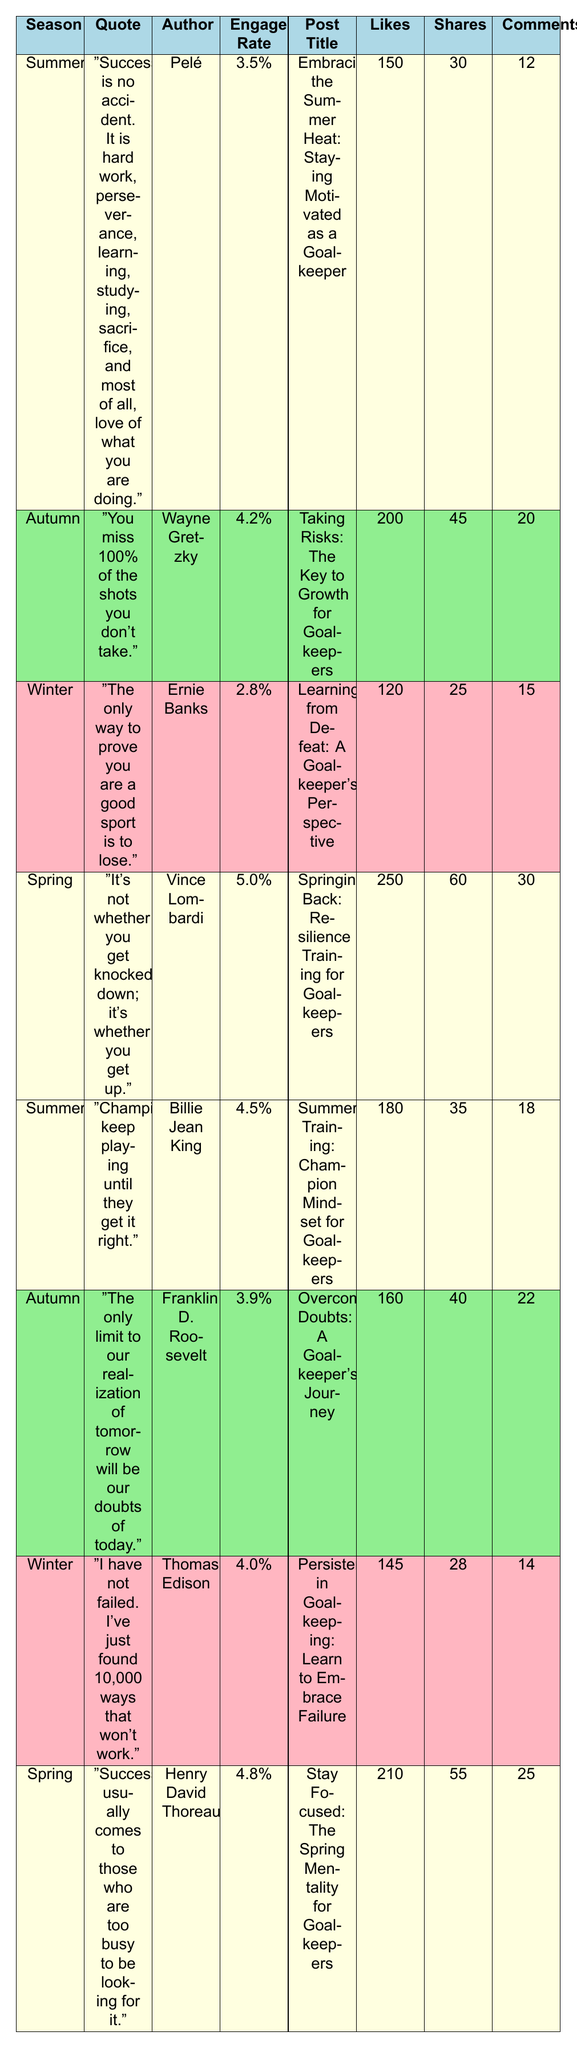What is the highest engagement rate among the quotes? The highest engagement rate in the table is 5.0%, which corresponds to Vince Lombardi's quote during Spring.
Answer: 5.0% Which quote by Wayne Gretzky is associated with the Autumn season? Wayne Gretzky's quote, "You miss 100% of the shots you don’t take," is listed as the quote for Autumn in the table.
Answer: "You miss 100% of the shots you don’t take." What is the total number of likes for all posts in the Summer season? The Summer posts have 150 likes from Pelé's quote and 180 likes from Billie Jean King’s quote. Summing these gives 150 + 180 = 330 likes.
Answer: 330 Which season has the quote with the lowest engagement rate? The Winter season has the lowest engagement rate of 2.8%, associated with Ernie Banks' quote.
Answer: Winter What is the average number of comments across all quotes? The total comments are 12 + 20 + 15 + 30 + 18 + 22 + 14 + 25 = 156. There are 8 quotes, so the average is 156/8 = 19.5.
Answer: 19.5 Is there a quote in the Spring season that has an engagement rate higher than 4.5%? Yes, Vince Lombardi's quote in Spring has an engagement rate of 5.0%, which is indeed higher than 4.5%.
Answer: Yes Which quote received the highest number of likes, and what is that number? The quote by Vince Lombardi received the highest number of likes at 250.
Answer: 250 What is the difference in engagement rates between the Winter and Spring seasons? The Winter season has an engagement rate of 2.8% and Spring has 5.0%. The difference is 5.0% - 2.8% = 2.2%.
Answer: 2.2% Are there any quotes from Autumn having an engagement rate above 4.0%? Yes, Wayne Gretzky's quote has an engagement rate of 4.2%, which is above 4.0%.
Answer: Yes 